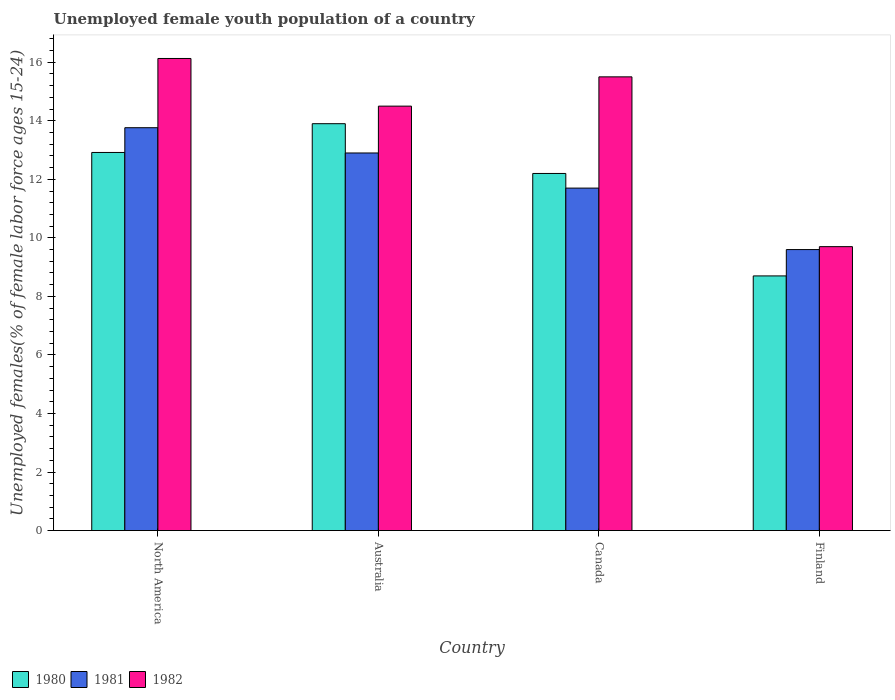How many groups of bars are there?
Your answer should be very brief. 4. Are the number of bars on each tick of the X-axis equal?
Keep it short and to the point. Yes. How many bars are there on the 2nd tick from the left?
Provide a succinct answer. 3. What is the label of the 3rd group of bars from the left?
Provide a short and direct response. Canada. In how many cases, is the number of bars for a given country not equal to the number of legend labels?
Your answer should be very brief. 0. What is the percentage of unemployed female youth population in 1982 in North America?
Make the answer very short. 16.13. Across all countries, what is the maximum percentage of unemployed female youth population in 1981?
Keep it short and to the point. 13.76. Across all countries, what is the minimum percentage of unemployed female youth population in 1982?
Provide a succinct answer. 9.7. In which country was the percentage of unemployed female youth population in 1981 maximum?
Your answer should be compact. North America. In which country was the percentage of unemployed female youth population in 1981 minimum?
Your answer should be very brief. Finland. What is the total percentage of unemployed female youth population in 1981 in the graph?
Offer a very short reply. 47.96. What is the difference between the percentage of unemployed female youth population in 1981 in Canada and that in North America?
Your answer should be compact. -2.06. What is the difference between the percentage of unemployed female youth population in 1982 in Canada and the percentage of unemployed female youth population in 1981 in North America?
Keep it short and to the point. 1.74. What is the average percentage of unemployed female youth population in 1981 per country?
Give a very brief answer. 11.99. What is the difference between the percentage of unemployed female youth population of/in 1982 and percentage of unemployed female youth population of/in 1980 in Finland?
Offer a very short reply. 1. In how many countries, is the percentage of unemployed female youth population in 1980 greater than 9.6 %?
Offer a terse response. 3. What is the ratio of the percentage of unemployed female youth population in 1981 in Canada to that in North America?
Provide a succinct answer. 0.85. Is the percentage of unemployed female youth population in 1982 in Canada less than that in Finland?
Your answer should be very brief. No. What is the difference between the highest and the second highest percentage of unemployed female youth population in 1980?
Ensure brevity in your answer.  -0.98. What is the difference between the highest and the lowest percentage of unemployed female youth population in 1981?
Ensure brevity in your answer.  4.16. Is the sum of the percentage of unemployed female youth population in 1981 in Australia and Canada greater than the maximum percentage of unemployed female youth population in 1982 across all countries?
Make the answer very short. Yes. What does the 1st bar from the right in North America represents?
Provide a short and direct response. 1982. How many bars are there?
Keep it short and to the point. 12. Are all the bars in the graph horizontal?
Give a very brief answer. No. How many countries are there in the graph?
Offer a very short reply. 4. What is the difference between two consecutive major ticks on the Y-axis?
Give a very brief answer. 2. Does the graph contain grids?
Provide a succinct answer. No. How are the legend labels stacked?
Offer a very short reply. Horizontal. What is the title of the graph?
Give a very brief answer. Unemployed female youth population of a country. What is the label or title of the X-axis?
Offer a very short reply. Country. What is the label or title of the Y-axis?
Offer a terse response. Unemployed females(% of female labor force ages 15-24). What is the Unemployed females(% of female labor force ages 15-24) of 1980 in North America?
Offer a terse response. 12.92. What is the Unemployed females(% of female labor force ages 15-24) of 1981 in North America?
Provide a short and direct response. 13.76. What is the Unemployed females(% of female labor force ages 15-24) of 1982 in North America?
Make the answer very short. 16.13. What is the Unemployed females(% of female labor force ages 15-24) of 1980 in Australia?
Provide a succinct answer. 13.9. What is the Unemployed females(% of female labor force ages 15-24) of 1981 in Australia?
Your answer should be compact. 12.9. What is the Unemployed females(% of female labor force ages 15-24) of 1982 in Australia?
Your answer should be very brief. 14.5. What is the Unemployed females(% of female labor force ages 15-24) of 1980 in Canada?
Keep it short and to the point. 12.2. What is the Unemployed females(% of female labor force ages 15-24) in 1981 in Canada?
Offer a terse response. 11.7. What is the Unemployed females(% of female labor force ages 15-24) in 1980 in Finland?
Provide a succinct answer. 8.7. What is the Unemployed females(% of female labor force ages 15-24) of 1981 in Finland?
Make the answer very short. 9.6. What is the Unemployed females(% of female labor force ages 15-24) in 1982 in Finland?
Provide a short and direct response. 9.7. Across all countries, what is the maximum Unemployed females(% of female labor force ages 15-24) in 1980?
Your answer should be compact. 13.9. Across all countries, what is the maximum Unemployed females(% of female labor force ages 15-24) in 1981?
Give a very brief answer. 13.76. Across all countries, what is the maximum Unemployed females(% of female labor force ages 15-24) of 1982?
Your answer should be compact. 16.13. Across all countries, what is the minimum Unemployed females(% of female labor force ages 15-24) in 1980?
Your answer should be compact. 8.7. Across all countries, what is the minimum Unemployed females(% of female labor force ages 15-24) of 1981?
Provide a succinct answer. 9.6. Across all countries, what is the minimum Unemployed females(% of female labor force ages 15-24) of 1982?
Give a very brief answer. 9.7. What is the total Unemployed females(% of female labor force ages 15-24) in 1980 in the graph?
Keep it short and to the point. 47.72. What is the total Unemployed females(% of female labor force ages 15-24) in 1981 in the graph?
Provide a succinct answer. 47.96. What is the total Unemployed females(% of female labor force ages 15-24) of 1982 in the graph?
Ensure brevity in your answer.  55.83. What is the difference between the Unemployed females(% of female labor force ages 15-24) in 1980 in North America and that in Australia?
Make the answer very short. -0.98. What is the difference between the Unemployed females(% of female labor force ages 15-24) of 1981 in North America and that in Australia?
Keep it short and to the point. 0.86. What is the difference between the Unemployed females(% of female labor force ages 15-24) of 1982 in North America and that in Australia?
Offer a terse response. 1.63. What is the difference between the Unemployed females(% of female labor force ages 15-24) of 1980 in North America and that in Canada?
Provide a short and direct response. 0.72. What is the difference between the Unemployed females(% of female labor force ages 15-24) in 1981 in North America and that in Canada?
Offer a terse response. 2.06. What is the difference between the Unemployed females(% of female labor force ages 15-24) in 1982 in North America and that in Canada?
Keep it short and to the point. 0.63. What is the difference between the Unemployed females(% of female labor force ages 15-24) in 1980 in North America and that in Finland?
Your response must be concise. 4.22. What is the difference between the Unemployed females(% of female labor force ages 15-24) of 1981 in North America and that in Finland?
Offer a terse response. 4.16. What is the difference between the Unemployed females(% of female labor force ages 15-24) of 1982 in North America and that in Finland?
Give a very brief answer. 6.43. What is the difference between the Unemployed females(% of female labor force ages 15-24) in 1980 in Australia and that in Canada?
Offer a very short reply. 1.7. What is the difference between the Unemployed females(% of female labor force ages 15-24) in 1982 in Australia and that in Finland?
Your answer should be compact. 4.8. What is the difference between the Unemployed females(% of female labor force ages 15-24) in 1980 in Canada and that in Finland?
Offer a very short reply. 3.5. What is the difference between the Unemployed females(% of female labor force ages 15-24) in 1982 in Canada and that in Finland?
Offer a very short reply. 5.8. What is the difference between the Unemployed females(% of female labor force ages 15-24) in 1980 in North America and the Unemployed females(% of female labor force ages 15-24) in 1981 in Australia?
Your response must be concise. 0.02. What is the difference between the Unemployed females(% of female labor force ages 15-24) in 1980 in North America and the Unemployed females(% of female labor force ages 15-24) in 1982 in Australia?
Your answer should be very brief. -1.58. What is the difference between the Unemployed females(% of female labor force ages 15-24) of 1981 in North America and the Unemployed females(% of female labor force ages 15-24) of 1982 in Australia?
Offer a very short reply. -0.74. What is the difference between the Unemployed females(% of female labor force ages 15-24) of 1980 in North America and the Unemployed females(% of female labor force ages 15-24) of 1981 in Canada?
Give a very brief answer. 1.22. What is the difference between the Unemployed females(% of female labor force ages 15-24) of 1980 in North America and the Unemployed females(% of female labor force ages 15-24) of 1982 in Canada?
Give a very brief answer. -2.58. What is the difference between the Unemployed females(% of female labor force ages 15-24) of 1981 in North America and the Unemployed females(% of female labor force ages 15-24) of 1982 in Canada?
Keep it short and to the point. -1.74. What is the difference between the Unemployed females(% of female labor force ages 15-24) in 1980 in North America and the Unemployed females(% of female labor force ages 15-24) in 1981 in Finland?
Give a very brief answer. 3.32. What is the difference between the Unemployed females(% of female labor force ages 15-24) in 1980 in North America and the Unemployed females(% of female labor force ages 15-24) in 1982 in Finland?
Your answer should be very brief. 3.22. What is the difference between the Unemployed females(% of female labor force ages 15-24) in 1981 in North America and the Unemployed females(% of female labor force ages 15-24) in 1982 in Finland?
Provide a short and direct response. 4.06. What is the difference between the Unemployed females(% of female labor force ages 15-24) in 1981 in Australia and the Unemployed females(% of female labor force ages 15-24) in 1982 in Canada?
Offer a very short reply. -2.6. What is the difference between the Unemployed females(% of female labor force ages 15-24) of 1980 in Canada and the Unemployed females(% of female labor force ages 15-24) of 1982 in Finland?
Provide a short and direct response. 2.5. What is the difference between the Unemployed females(% of female labor force ages 15-24) of 1981 in Canada and the Unemployed females(% of female labor force ages 15-24) of 1982 in Finland?
Offer a very short reply. 2. What is the average Unemployed females(% of female labor force ages 15-24) of 1980 per country?
Give a very brief answer. 11.93. What is the average Unemployed females(% of female labor force ages 15-24) of 1981 per country?
Provide a short and direct response. 11.99. What is the average Unemployed females(% of female labor force ages 15-24) in 1982 per country?
Offer a terse response. 13.96. What is the difference between the Unemployed females(% of female labor force ages 15-24) in 1980 and Unemployed females(% of female labor force ages 15-24) in 1981 in North America?
Offer a very short reply. -0.85. What is the difference between the Unemployed females(% of female labor force ages 15-24) in 1980 and Unemployed females(% of female labor force ages 15-24) in 1982 in North America?
Make the answer very short. -3.21. What is the difference between the Unemployed females(% of female labor force ages 15-24) of 1981 and Unemployed females(% of female labor force ages 15-24) of 1982 in North America?
Make the answer very short. -2.37. What is the difference between the Unemployed females(% of female labor force ages 15-24) in 1980 and Unemployed females(% of female labor force ages 15-24) in 1982 in Australia?
Keep it short and to the point. -0.6. What is the difference between the Unemployed females(% of female labor force ages 15-24) in 1981 and Unemployed females(% of female labor force ages 15-24) in 1982 in Australia?
Offer a very short reply. -1.6. What is the difference between the Unemployed females(% of female labor force ages 15-24) of 1980 and Unemployed females(% of female labor force ages 15-24) of 1981 in Canada?
Ensure brevity in your answer.  0.5. What is the difference between the Unemployed females(% of female labor force ages 15-24) of 1981 and Unemployed females(% of female labor force ages 15-24) of 1982 in Canada?
Give a very brief answer. -3.8. What is the difference between the Unemployed females(% of female labor force ages 15-24) of 1980 and Unemployed females(% of female labor force ages 15-24) of 1982 in Finland?
Your answer should be very brief. -1. What is the difference between the Unemployed females(% of female labor force ages 15-24) in 1981 and Unemployed females(% of female labor force ages 15-24) in 1982 in Finland?
Provide a succinct answer. -0.1. What is the ratio of the Unemployed females(% of female labor force ages 15-24) in 1980 in North America to that in Australia?
Provide a succinct answer. 0.93. What is the ratio of the Unemployed females(% of female labor force ages 15-24) of 1981 in North America to that in Australia?
Your answer should be very brief. 1.07. What is the ratio of the Unemployed females(% of female labor force ages 15-24) of 1982 in North America to that in Australia?
Make the answer very short. 1.11. What is the ratio of the Unemployed females(% of female labor force ages 15-24) of 1980 in North America to that in Canada?
Offer a terse response. 1.06. What is the ratio of the Unemployed females(% of female labor force ages 15-24) of 1981 in North America to that in Canada?
Offer a very short reply. 1.18. What is the ratio of the Unemployed females(% of female labor force ages 15-24) of 1982 in North America to that in Canada?
Ensure brevity in your answer.  1.04. What is the ratio of the Unemployed females(% of female labor force ages 15-24) of 1980 in North America to that in Finland?
Give a very brief answer. 1.48. What is the ratio of the Unemployed females(% of female labor force ages 15-24) in 1981 in North America to that in Finland?
Ensure brevity in your answer.  1.43. What is the ratio of the Unemployed females(% of female labor force ages 15-24) in 1982 in North America to that in Finland?
Offer a very short reply. 1.66. What is the ratio of the Unemployed females(% of female labor force ages 15-24) of 1980 in Australia to that in Canada?
Offer a very short reply. 1.14. What is the ratio of the Unemployed females(% of female labor force ages 15-24) of 1981 in Australia to that in Canada?
Ensure brevity in your answer.  1.1. What is the ratio of the Unemployed females(% of female labor force ages 15-24) of 1982 in Australia to that in Canada?
Your answer should be compact. 0.94. What is the ratio of the Unemployed females(% of female labor force ages 15-24) of 1980 in Australia to that in Finland?
Give a very brief answer. 1.6. What is the ratio of the Unemployed females(% of female labor force ages 15-24) in 1981 in Australia to that in Finland?
Make the answer very short. 1.34. What is the ratio of the Unemployed females(% of female labor force ages 15-24) of 1982 in Australia to that in Finland?
Keep it short and to the point. 1.49. What is the ratio of the Unemployed females(% of female labor force ages 15-24) in 1980 in Canada to that in Finland?
Provide a succinct answer. 1.4. What is the ratio of the Unemployed females(% of female labor force ages 15-24) of 1981 in Canada to that in Finland?
Provide a succinct answer. 1.22. What is the ratio of the Unemployed females(% of female labor force ages 15-24) of 1982 in Canada to that in Finland?
Offer a very short reply. 1.6. What is the difference between the highest and the second highest Unemployed females(% of female labor force ages 15-24) in 1980?
Provide a succinct answer. 0.98. What is the difference between the highest and the second highest Unemployed females(% of female labor force ages 15-24) in 1981?
Make the answer very short. 0.86. What is the difference between the highest and the second highest Unemployed females(% of female labor force ages 15-24) of 1982?
Give a very brief answer. 0.63. What is the difference between the highest and the lowest Unemployed females(% of female labor force ages 15-24) in 1981?
Offer a very short reply. 4.16. What is the difference between the highest and the lowest Unemployed females(% of female labor force ages 15-24) in 1982?
Give a very brief answer. 6.43. 